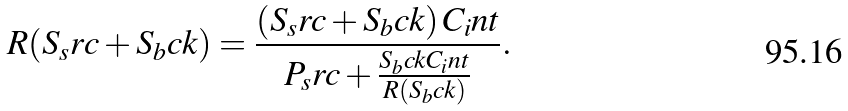Convert formula to latex. <formula><loc_0><loc_0><loc_500><loc_500>R ( S _ { s } r c + S _ { b } c k ) = \frac { ( S _ { s } r c + S _ { b } c k ) \, C _ { i } n t } { P _ { s } r c + \frac { S _ { b } c k C _ { i } n t } { R ( S _ { b } c k ) } } .</formula> 